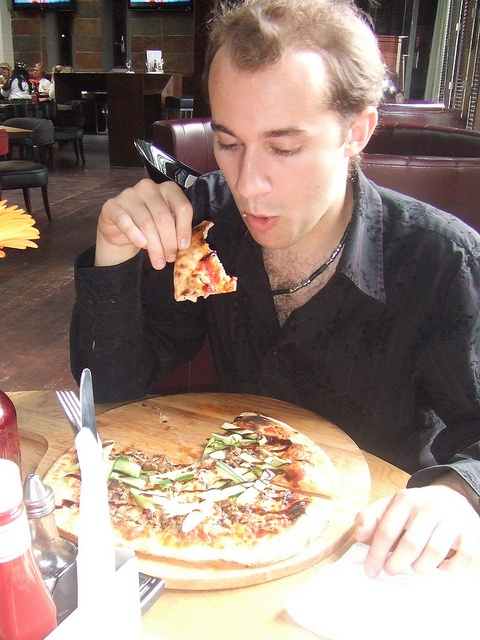Describe the objects in this image and their specific colors. I can see people in gray, black, tan, and white tones, dining table in gray, ivory, and tan tones, pizza in gray, ivory, and tan tones, pizza in gray, beige, khaki, tan, and brown tones, and bottle in gray, white, and salmon tones in this image. 